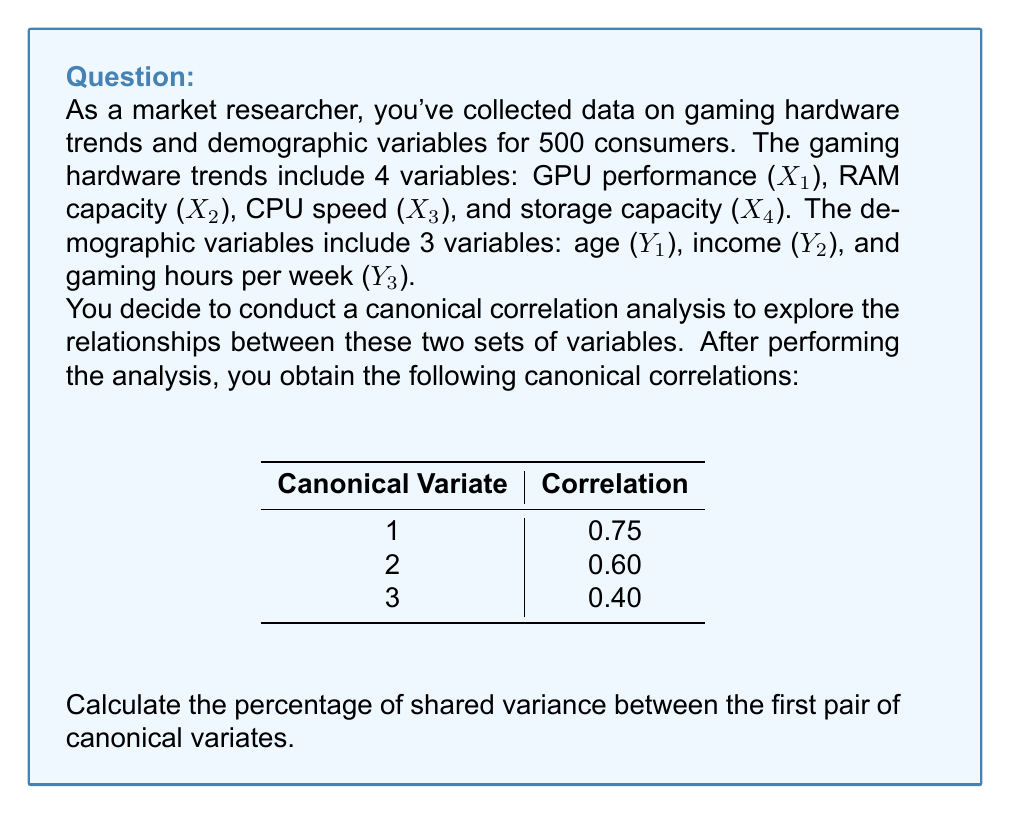Show me your answer to this math problem. To calculate the percentage of shared variance between the first pair of canonical variates, we need to follow these steps:

1) The shared variance is equal to the square of the canonical correlation. This is also known as the canonical R-squared.

2) For the first pair of canonical variates, the correlation is 0.75.

3) Calculate the square of this correlation:

   $$R_c^2 = (0.75)^2 = 0.5625$$

4) To express this as a percentage, multiply by 100:

   $$0.5625 \times 100 = 56.25\%$$

Therefore, the first pair of canonical variates shares 56.25% of their variance.

This means that 56.25% of the variance in the first canonical variate of the gaming hardware trends can be explained by the first canonical variate of the demographic variables, and vice versa.

This relatively high shared variance suggests a strong relationship between the first pair of canonical variates, indicating that there's a significant association between certain combinations of gaming hardware trends and demographic variables.
Answer: 56.25% 